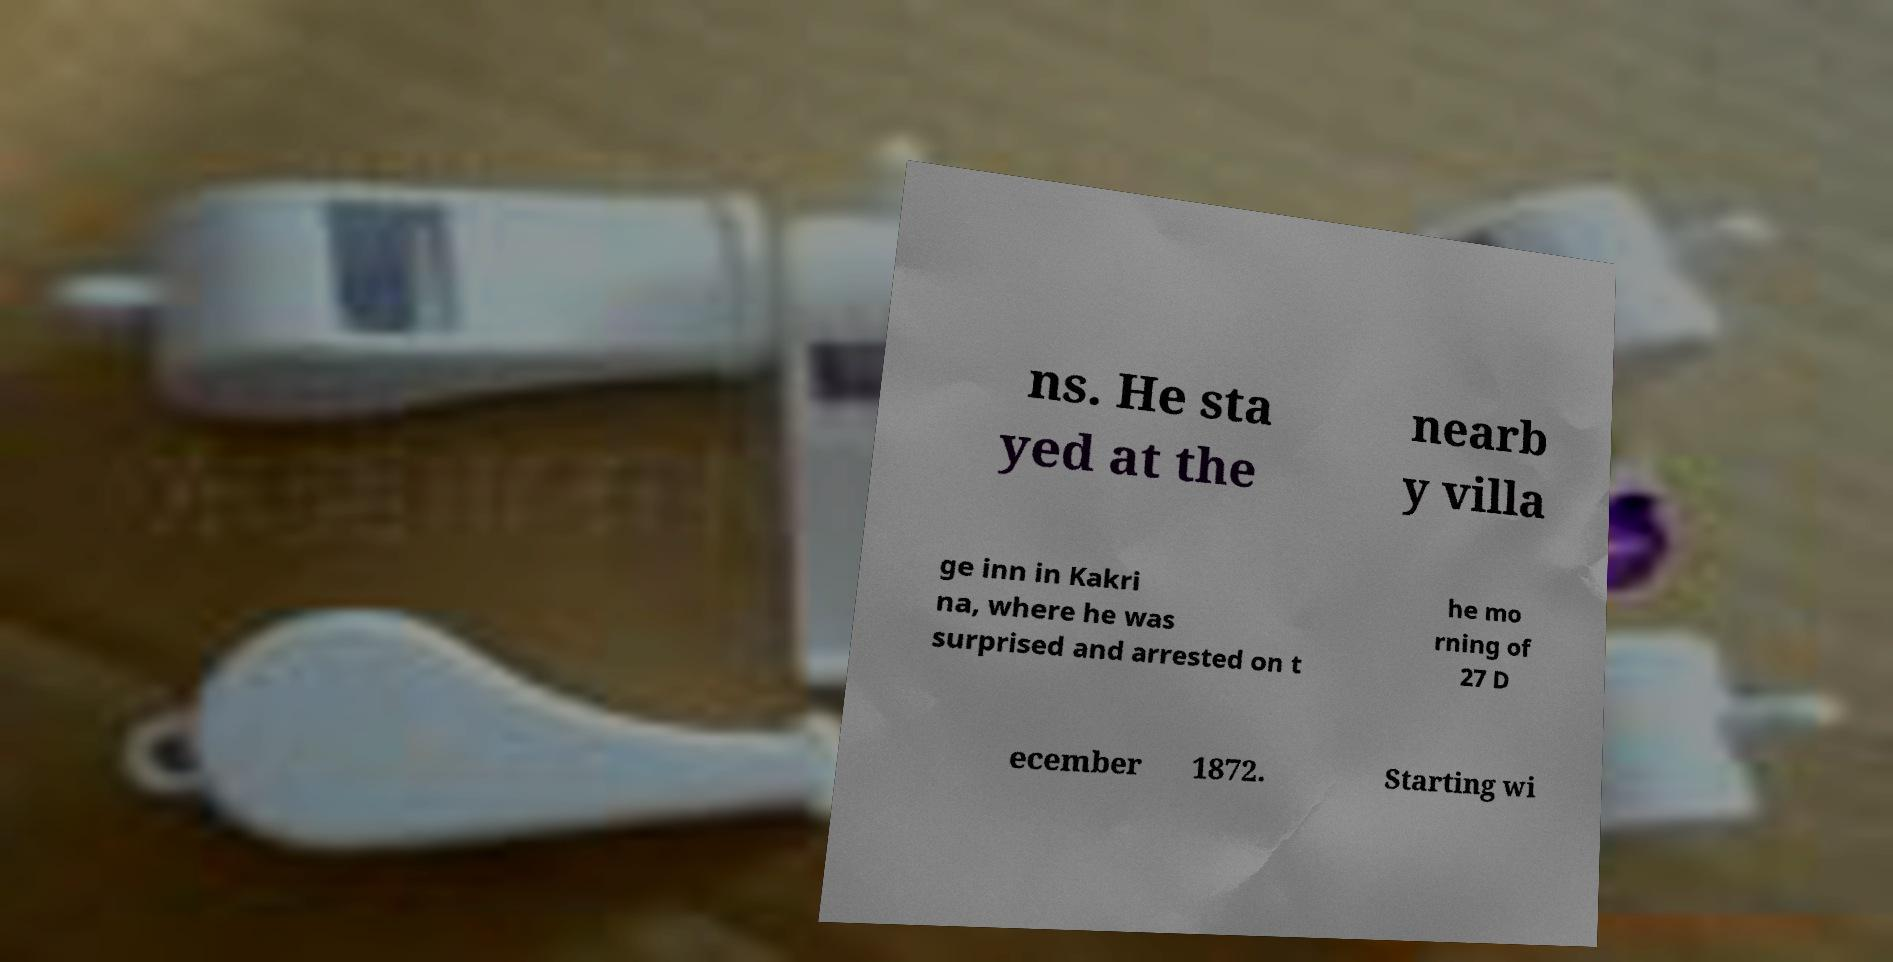Please read and relay the text visible in this image. What does it say? ns. He sta yed at the nearb y villa ge inn in Kakri na, where he was surprised and arrested on t he mo rning of 27 D ecember 1872. Starting wi 